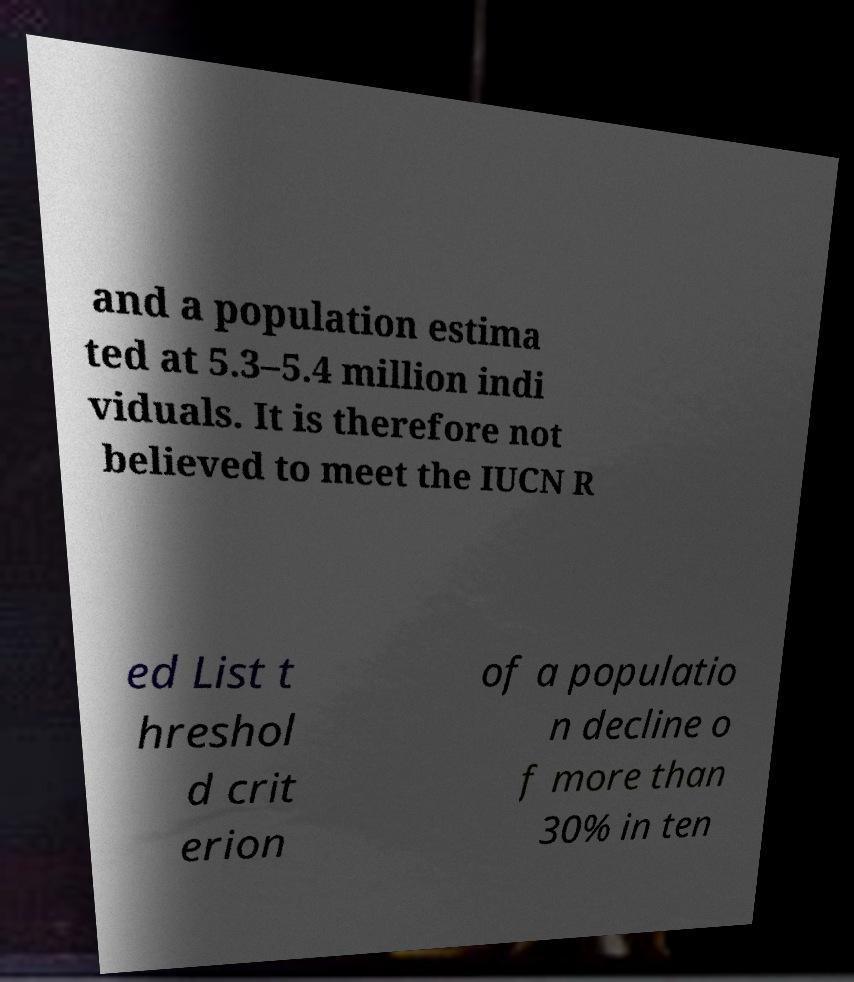For documentation purposes, I need the text within this image transcribed. Could you provide that? and a population estima ted at 5.3–5.4 million indi viduals. It is therefore not believed to meet the IUCN R ed List t hreshol d crit erion of a populatio n decline o f more than 30% in ten 